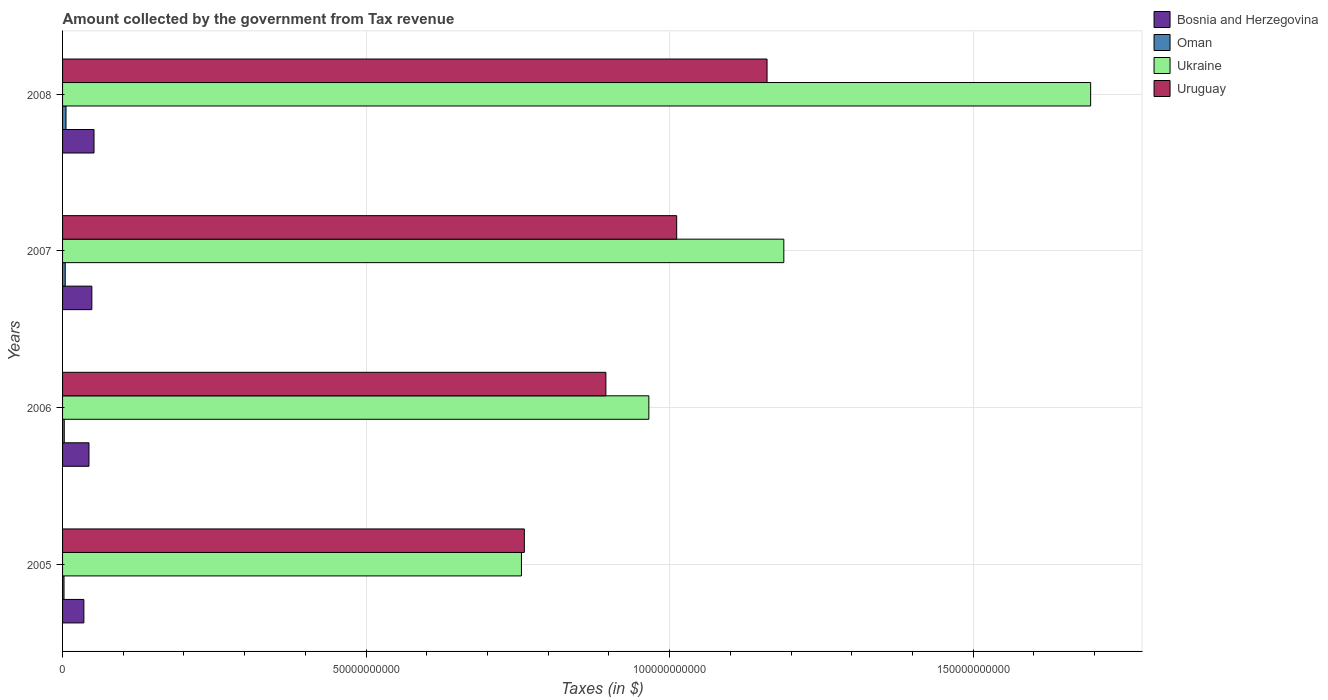Are the number of bars per tick equal to the number of legend labels?
Provide a short and direct response. Yes. How many bars are there on the 3rd tick from the bottom?
Your response must be concise. 4. What is the label of the 1st group of bars from the top?
Ensure brevity in your answer.  2008. In how many cases, is the number of bars for a given year not equal to the number of legend labels?
Ensure brevity in your answer.  0. What is the amount collected by the government from tax revenue in Oman in 2008?
Your answer should be compact. 5.66e+08. Across all years, what is the maximum amount collected by the government from tax revenue in Bosnia and Herzegovina?
Your answer should be very brief. 5.18e+09. Across all years, what is the minimum amount collected by the government from tax revenue in Uruguay?
Your answer should be compact. 7.61e+1. In which year was the amount collected by the government from tax revenue in Uruguay minimum?
Your answer should be very brief. 2005. What is the total amount collected by the government from tax revenue in Oman in the graph?
Offer a very short reply. 1.52e+09. What is the difference between the amount collected by the government from tax revenue in Oman in 2006 and that in 2008?
Provide a succinct answer. -2.88e+08. What is the difference between the amount collected by the government from tax revenue in Oman in 2005 and the amount collected by the government from tax revenue in Bosnia and Herzegovina in 2008?
Keep it short and to the point. -4.94e+09. What is the average amount collected by the government from tax revenue in Oman per year?
Make the answer very short. 3.80e+08. In the year 2006, what is the difference between the amount collected by the government from tax revenue in Uruguay and amount collected by the government from tax revenue in Bosnia and Herzegovina?
Your answer should be very brief. 8.51e+1. What is the ratio of the amount collected by the government from tax revenue in Oman in 2005 to that in 2006?
Make the answer very short. 0.86. What is the difference between the highest and the second highest amount collected by the government from tax revenue in Oman?
Your answer should be compact. 1.28e+08. What is the difference between the highest and the lowest amount collected by the government from tax revenue in Oman?
Provide a succinct answer. 3.27e+08. In how many years, is the amount collected by the government from tax revenue in Bosnia and Herzegovina greater than the average amount collected by the government from tax revenue in Bosnia and Herzegovina taken over all years?
Provide a succinct answer. 2. Is the sum of the amount collected by the government from tax revenue in Ukraine in 2005 and 2006 greater than the maximum amount collected by the government from tax revenue in Bosnia and Herzegovina across all years?
Your answer should be compact. Yes. Is it the case that in every year, the sum of the amount collected by the government from tax revenue in Oman and amount collected by the government from tax revenue in Ukraine is greater than the sum of amount collected by the government from tax revenue in Bosnia and Herzegovina and amount collected by the government from tax revenue in Uruguay?
Provide a short and direct response. Yes. What does the 2nd bar from the top in 2005 represents?
Give a very brief answer. Ukraine. What does the 2nd bar from the bottom in 2007 represents?
Ensure brevity in your answer.  Oman. Is it the case that in every year, the sum of the amount collected by the government from tax revenue in Oman and amount collected by the government from tax revenue in Bosnia and Herzegovina is greater than the amount collected by the government from tax revenue in Ukraine?
Your answer should be very brief. No. Are all the bars in the graph horizontal?
Your answer should be compact. Yes. How many years are there in the graph?
Your answer should be very brief. 4. Does the graph contain grids?
Provide a succinct answer. Yes. Where does the legend appear in the graph?
Your answer should be compact. Top right. How are the legend labels stacked?
Keep it short and to the point. Vertical. What is the title of the graph?
Provide a short and direct response. Amount collected by the government from Tax revenue. Does "Hungary" appear as one of the legend labels in the graph?
Keep it short and to the point. No. What is the label or title of the X-axis?
Provide a short and direct response. Taxes (in $). What is the label or title of the Y-axis?
Offer a terse response. Years. What is the Taxes (in $) of Bosnia and Herzegovina in 2005?
Your answer should be very brief. 3.51e+09. What is the Taxes (in $) in Oman in 2005?
Your response must be concise. 2.39e+08. What is the Taxes (in $) of Ukraine in 2005?
Provide a succinct answer. 7.56e+1. What is the Taxes (in $) of Uruguay in 2005?
Your response must be concise. 7.61e+1. What is the Taxes (in $) of Bosnia and Herzegovina in 2006?
Offer a very short reply. 4.35e+09. What is the Taxes (in $) in Oman in 2006?
Give a very brief answer. 2.78e+08. What is the Taxes (in $) in Ukraine in 2006?
Ensure brevity in your answer.  9.66e+1. What is the Taxes (in $) of Uruguay in 2006?
Your response must be concise. 8.95e+1. What is the Taxes (in $) in Bosnia and Herzegovina in 2007?
Ensure brevity in your answer.  4.82e+09. What is the Taxes (in $) of Oman in 2007?
Give a very brief answer. 4.38e+08. What is the Taxes (in $) of Ukraine in 2007?
Ensure brevity in your answer.  1.19e+11. What is the Taxes (in $) of Uruguay in 2007?
Offer a very short reply. 1.01e+11. What is the Taxes (in $) of Bosnia and Herzegovina in 2008?
Offer a terse response. 5.18e+09. What is the Taxes (in $) in Oman in 2008?
Provide a short and direct response. 5.66e+08. What is the Taxes (in $) of Ukraine in 2008?
Your answer should be very brief. 1.69e+11. What is the Taxes (in $) of Uruguay in 2008?
Provide a succinct answer. 1.16e+11. Across all years, what is the maximum Taxes (in $) of Bosnia and Herzegovina?
Ensure brevity in your answer.  5.18e+09. Across all years, what is the maximum Taxes (in $) in Oman?
Provide a short and direct response. 5.66e+08. Across all years, what is the maximum Taxes (in $) in Ukraine?
Ensure brevity in your answer.  1.69e+11. Across all years, what is the maximum Taxes (in $) in Uruguay?
Offer a terse response. 1.16e+11. Across all years, what is the minimum Taxes (in $) in Bosnia and Herzegovina?
Give a very brief answer. 3.51e+09. Across all years, what is the minimum Taxes (in $) of Oman?
Offer a terse response. 2.39e+08. Across all years, what is the minimum Taxes (in $) of Ukraine?
Ensure brevity in your answer.  7.56e+1. Across all years, what is the minimum Taxes (in $) of Uruguay?
Make the answer very short. 7.61e+1. What is the total Taxes (in $) of Bosnia and Herzegovina in the graph?
Your answer should be compact. 1.79e+1. What is the total Taxes (in $) in Oman in the graph?
Provide a succinct answer. 1.52e+09. What is the total Taxes (in $) in Ukraine in the graph?
Ensure brevity in your answer.  4.60e+11. What is the total Taxes (in $) in Uruguay in the graph?
Ensure brevity in your answer.  3.83e+11. What is the difference between the Taxes (in $) of Bosnia and Herzegovina in 2005 and that in 2006?
Make the answer very short. -8.40e+08. What is the difference between the Taxes (in $) in Oman in 2005 and that in 2006?
Provide a succinct answer. -3.95e+07. What is the difference between the Taxes (in $) in Ukraine in 2005 and that in 2006?
Provide a succinct answer. -2.10e+1. What is the difference between the Taxes (in $) of Uruguay in 2005 and that in 2006?
Give a very brief answer. -1.34e+1. What is the difference between the Taxes (in $) of Bosnia and Herzegovina in 2005 and that in 2007?
Offer a terse response. -1.31e+09. What is the difference between the Taxes (in $) in Oman in 2005 and that in 2007?
Your answer should be compact. -1.99e+08. What is the difference between the Taxes (in $) in Ukraine in 2005 and that in 2007?
Offer a very short reply. -4.32e+1. What is the difference between the Taxes (in $) of Uruguay in 2005 and that in 2007?
Offer a very short reply. -2.51e+1. What is the difference between the Taxes (in $) of Bosnia and Herzegovina in 2005 and that in 2008?
Offer a terse response. -1.67e+09. What is the difference between the Taxes (in $) of Oman in 2005 and that in 2008?
Your answer should be very brief. -3.27e+08. What is the difference between the Taxes (in $) in Ukraine in 2005 and that in 2008?
Provide a short and direct response. -9.38e+1. What is the difference between the Taxes (in $) of Uruguay in 2005 and that in 2008?
Provide a succinct answer. -4.00e+1. What is the difference between the Taxes (in $) of Bosnia and Herzegovina in 2006 and that in 2007?
Your answer should be compact. -4.74e+08. What is the difference between the Taxes (in $) in Oman in 2006 and that in 2007?
Give a very brief answer. -1.59e+08. What is the difference between the Taxes (in $) in Ukraine in 2006 and that in 2007?
Your answer should be very brief. -2.22e+1. What is the difference between the Taxes (in $) of Uruguay in 2006 and that in 2007?
Keep it short and to the point. -1.17e+1. What is the difference between the Taxes (in $) of Bosnia and Herzegovina in 2006 and that in 2008?
Your response must be concise. -8.31e+08. What is the difference between the Taxes (in $) in Oman in 2006 and that in 2008?
Offer a very short reply. -2.88e+08. What is the difference between the Taxes (in $) in Ukraine in 2006 and that in 2008?
Provide a short and direct response. -7.28e+1. What is the difference between the Taxes (in $) of Uruguay in 2006 and that in 2008?
Keep it short and to the point. -2.65e+1. What is the difference between the Taxes (in $) of Bosnia and Herzegovina in 2007 and that in 2008?
Ensure brevity in your answer.  -3.57e+08. What is the difference between the Taxes (in $) in Oman in 2007 and that in 2008?
Provide a short and direct response. -1.28e+08. What is the difference between the Taxes (in $) of Ukraine in 2007 and that in 2008?
Provide a succinct answer. -5.05e+1. What is the difference between the Taxes (in $) of Uruguay in 2007 and that in 2008?
Ensure brevity in your answer.  -1.49e+1. What is the difference between the Taxes (in $) of Bosnia and Herzegovina in 2005 and the Taxes (in $) of Oman in 2006?
Provide a short and direct response. 3.23e+09. What is the difference between the Taxes (in $) in Bosnia and Herzegovina in 2005 and the Taxes (in $) in Ukraine in 2006?
Your answer should be very brief. -9.31e+1. What is the difference between the Taxes (in $) in Bosnia and Herzegovina in 2005 and the Taxes (in $) in Uruguay in 2006?
Provide a short and direct response. -8.60e+1. What is the difference between the Taxes (in $) of Oman in 2005 and the Taxes (in $) of Ukraine in 2006?
Your answer should be compact. -9.63e+1. What is the difference between the Taxes (in $) of Oman in 2005 and the Taxes (in $) of Uruguay in 2006?
Provide a succinct answer. -8.93e+1. What is the difference between the Taxes (in $) in Ukraine in 2005 and the Taxes (in $) in Uruguay in 2006?
Ensure brevity in your answer.  -1.39e+1. What is the difference between the Taxes (in $) of Bosnia and Herzegovina in 2005 and the Taxes (in $) of Oman in 2007?
Give a very brief answer. 3.07e+09. What is the difference between the Taxes (in $) of Bosnia and Herzegovina in 2005 and the Taxes (in $) of Ukraine in 2007?
Keep it short and to the point. -1.15e+11. What is the difference between the Taxes (in $) of Bosnia and Herzegovina in 2005 and the Taxes (in $) of Uruguay in 2007?
Provide a short and direct response. -9.77e+1. What is the difference between the Taxes (in $) of Oman in 2005 and the Taxes (in $) of Ukraine in 2007?
Ensure brevity in your answer.  -1.19e+11. What is the difference between the Taxes (in $) in Oman in 2005 and the Taxes (in $) in Uruguay in 2007?
Provide a short and direct response. -1.01e+11. What is the difference between the Taxes (in $) of Ukraine in 2005 and the Taxes (in $) of Uruguay in 2007?
Provide a short and direct response. -2.56e+1. What is the difference between the Taxes (in $) in Bosnia and Herzegovina in 2005 and the Taxes (in $) in Oman in 2008?
Your answer should be compact. 2.94e+09. What is the difference between the Taxes (in $) of Bosnia and Herzegovina in 2005 and the Taxes (in $) of Ukraine in 2008?
Keep it short and to the point. -1.66e+11. What is the difference between the Taxes (in $) in Bosnia and Herzegovina in 2005 and the Taxes (in $) in Uruguay in 2008?
Provide a succinct answer. -1.13e+11. What is the difference between the Taxes (in $) in Oman in 2005 and the Taxes (in $) in Ukraine in 2008?
Provide a short and direct response. -1.69e+11. What is the difference between the Taxes (in $) in Oman in 2005 and the Taxes (in $) in Uruguay in 2008?
Offer a terse response. -1.16e+11. What is the difference between the Taxes (in $) in Ukraine in 2005 and the Taxes (in $) in Uruguay in 2008?
Give a very brief answer. -4.05e+1. What is the difference between the Taxes (in $) of Bosnia and Herzegovina in 2006 and the Taxes (in $) of Oman in 2007?
Provide a succinct answer. 3.91e+09. What is the difference between the Taxes (in $) in Bosnia and Herzegovina in 2006 and the Taxes (in $) in Ukraine in 2007?
Keep it short and to the point. -1.14e+11. What is the difference between the Taxes (in $) of Bosnia and Herzegovina in 2006 and the Taxes (in $) of Uruguay in 2007?
Keep it short and to the point. -9.68e+1. What is the difference between the Taxes (in $) of Oman in 2006 and the Taxes (in $) of Ukraine in 2007?
Provide a short and direct response. -1.19e+11. What is the difference between the Taxes (in $) in Oman in 2006 and the Taxes (in $) in Uruguay in 2007?
Provide a succinct answer. -1.01e+11. What is the difference between the Taxes (in $) of Ukraine in 2006 and the Taxes (in $) of Uruguay in 2007?
Provide a succinct answer. -4.59e+09. What is the difference between the Taxes (in $) of Bosnia and Herzegovina in 2006 and the Taxes (in $) of Oman in 2008?
Offer a very short reply. 3.78e+09. What is the difference between the Taxes (in $) in Bosnia and Herzegovina in 2006 and the Taxes (in $) in Ukraine in 2008?
Your answer should be compact. -1.65e+11. What is the difference between the Taxes (in $) of Bosnia and Herzegovina in 2006 and the Taxes (in $) of Uruguay in 2008?
Give a very brief answer. -1.12e+11. What is the difference between the Taxes (in $) of Oman in 2006 and the Taxes (in $) of Ukraine in 2008?
Your response must be concise. -1.69e+11. What is the difference between the Taxes (in $) in Oman in 2006 and the Taxes (in $) in Uruguay in 2008?
Your response must be concise. -1.16e+11. What is the difference between the Taxes (in $) of Ukraine in 2006 and the Taxes (in $) of Uruguay in 2008?
Your answer should be compact. -1.95e+1. What is the difference between the Taxes (in $) in Bosnia and Herzegovina in 2007 and the Taxes (in $) in Oman in 2008?
Ensure brevity in your answer.  4.26e+09. What is the difference between the Taxes (in $) of Bosnia and Herzegovina in 2007 and the Taxes (in $) of Ukraine in 2008?
Ensure brevity in your answer.  -1.65e+11. What is the difference between the Taxes (in $) in Bosnia and Herzegovina in 2007 and the Taxes (in $) in Uruguay in 2008?
Your answer should be compact. -1.11e+11. What is the difference between the Taxes (in $) of Oman in 2007 and the Taxes (in $) of Ukraine in 2008?
Offer a terse response. -1.69e+11. What is the difference between the Taxes (in $) of Oman in 2007 and the Taxes (in $) of Uruguay in 2008?
Your response must be concise. -1.16e+11. What is the difference between the Taxes (in $) in Ukraine in 2007 and the Taxes (in $) in Uruguay in 2008?
Your response must be concise. 2.76e+09. What is the average Taxes (in $) in Bosnia and Herzegovina per year?
Your response must be concise. 4.47e+09. What is the average Taxes (in $) in Oman per year?
Keep it short and to the point. 3.80e+08. What is the average Taxes (in $) in Ukraine per year?
Offer a terse response. 1.15e+11. What is the average Taxes (in $) in Uruguay per year?
Provide a short and direct response. 9.57e+1. In the year 2005, what is the difference between the Taxes (in $) of Bosnia and Herzegovina and Taxes (in $) of Oman?
Offer a terse response. 3.27e+09. In the year 2005, what is the difference between the Taxes (in $) of Bosnia and Herzegovina and Taxes (in $) of Ukraine?
Offer a terse response. -7.21e+1. In the year 2005, what is the difference between the Taxes (in $) in Bosnia and Herzegovina and Taxes (in $) in Uruguay?
Make the answer very short. -7.26e+1. In the year 2005, what is the difference between the Taxes (in $) of Oman and Taxes (in $) of Ukraine?
Offer a terse response. -7.54e+1. In the year 2005, what is the difference between the Taxes (in $) in Oman and Taxes (in $) in Uruguay?
Your response must be concise. -7.58e+1. In the year 2005, what is the difference between the Taxes (in $) in Ukraine and Taxes (in $) in Uruguay?
Keep it short and to the point. -4.75e+08. In the year 2006, what is the difference between the Taxes (in $) in Bosnia and Herzegovina and Taxes (in $) in Oman?
Ensure brevity in your answer.  4.07e+09. In the year 2006, what is the difference between the Taxes (in $) of Bosnia and Herzegovina and Taxes (in $) of Ukraine?
Provide a short and direct response. -9.22e+1. In the year 2006, what is the difference between the Taxes (in $) of Bosnia and Herzegovina and Taxes (in $) of Uruguay?
Your answer should be compact. -8.51e+1. In the year 2006, what is the difference between the Taxes (in $) of Oman and Taxes (in $) of Ukraine?
Your answer should be compact. -9.63e+1. In the year 2006, what is the difference between the Taxes (in $) in Oman and Taxes (in $) in Uruguay?
Your response must be concise. -8.92e+1. In the year 2006, what is the difference between the Taxes (in $) of Ukraine and Taxes (in $) of Uruguay?
Offer a very short reply. 7.07e+09. In the year 2007, what is the difference between the Taxes (in $) of Bosnia and Herzegovina and Taxes (in $) of Oman?
Make the answer very short. 4.39e+09. In the year 2007, what is the difference between the Taxes (in $) of Bosnia and Herzegovina and Taxes (in $) of Ukraine?
Make the answer very short. -1.14e+11. In the year 2007, what is the difference between the Taxes (in $) of Bosnia and Herzegovina and Taxes (in $) of Uruguay?
Provide a succinct answer. -9.63e+1. In the year 2007, what is the difference between the Taxes (in $) in Oman and Taxes (in $) in Ukraine?
Provide a succinct answer. -1.18e+11. In the year 2007, what is the difference between the Taxes (in $) of Oman and Taxes (in $) of Uruguay?
Your response must be concise. -1.01e+11. In the year 2007, what is the difference between the Taxes (in $) in Ukraine and Taxes (in $) in Uruguay?
Your response must be concise. 1.76e+1. In the year 2008, what is the difference between the Taxes (in $) in Bosnia and Herzegovina and Taxes (in $) in Oman?
Give a very brief answer. 4.62e+09. In the year 2008, what is the difference between the Taxes (in $) of Bosnia and Herzegovina and Taxes (in $) of Ukraine?
Keep it short and to the point. -1.64e+11. In the year 2008, what is the difference between the Taxes (in $) of Bosnia and Herzegovina and Taxes (in $) of Uruguay?
Offer a very short reply. -1.11e+11. In the year 2008, what is the difference between the Taxes (in $) in Oman and Taxes (in $) in Ukraine?
Offer a very short reply. -1.69e+11. In the year 2008, what is the difference between the Taxes (in $) of Oman and Taxes (in $) of Uruguay?
Make the answer very short. -1.15e+11. In the year 2008, what is the difference between the Taxes (in $) in Ukraine and Taxes (in $) in Uruguay?
Offer a terse response. 5.33e+1. What is the ratio of the Taxes (in $) in Bosnia and Herzegovina in 2005 to that in 2006?
Provide a succinct answer. 0.81. What is the ratio of the Taxes (in $) of Oman in 2005 to that in 2006?
Provide a short and direct response. 0.86. What is the ratio of the Taxes (in $) of Ukraine in 2005 to that in 2006?
Offer a terse response. 0.78. What is the ratio of the Taxes (in $) of Uruguay in 2005 to that in 2006?
Keep it short and to the point. 0.85. What is the ratio of the Taxes (in $) of Bosnia and Herzegovina in 2005 to that in 2007?
Offer a very short reply. 0.73. What is the ratio of the Taxes (in $) in Oman in 2005 to that in 2007?
Offer a terse response. 0.55. What is the ratio of the Taxes (in $) in Ukraine in 2005 to that in 2007?
Offer a very short reply. 0.64. What is the ratio of the Taxes (in $) in Uruguay in 2005 to that in 2007?
Provide a succinct answer. 0.75. What is the ratio of the Taxes (in $) of Bosnia and Herzegovina in 2005 to that in 2008?
Your answer should be compact. 0.68. What is the ratio of the Taxes (in $) in Oman in 2005 to that in 2008?
Your answer should be compact. 0.42. What is the ratio of the Taxes (in $) in Ukraine in 2005 to that in 2008?
Offer a very short reply. 0.45. What is the ratio of the Taxes (in $) of Uruguay in 2005 to that in 2008?
Offer a very short reply. 0.66. What is the ratio of the Taxes (in $) in Bosnia and Herzegovina in 2006 to that in 2007?
Provide a short and direct response. 0.9. What is the ratio of the Taxes (in $) in Oman in 2006 to that in 2007?
Give a very brief answer. 0.64. What is the ratio of the Taxes (in $) in Ukraine in 2006 to that in 2007?
Make the answer very short. 0.81. What is the ratio of the Taxes (in $) in Uruguay in 2006 to that in 2007?
Offer a very short reply. 0.88. What is the ratio of the Taxes (in $) of Bosnia and Herzegovina in 2006 to that in 2008?
Your response must be concise. 0.84. What is the ratio of the Taxes (in $) of Oman in 2006 to that in 2008?
Ensure brevity in your answer.  0.49. What is the ratio of the Taxes (in $) of Ukraine in 2006 to that in 2008?
Provide a short and direct response. 0.57. What is the ratio of the Taxes (in $) in Uruguay in 2006 to that in 2008?
Make the answer very short. 0.77. What is the ratio of the Taxes (in $) of Bosnia and Herzegovina in 2007 to that in 2008?
Offer a terse response. 0.93. What is the ratio of the Taxes (in $) of Oman in 2007 to that in 2008?
Provide a succinct answer. 0.77. What is the ratio of the Taxes (in $) of Ukraine in 2007 to that in 2008?
Keep it short and to the point. 0.7. What is the ratio of the Taxes (in $) in Uruguay in 2007 to that in 2008?
Make the answer very short. 0.87. What is the difference between the highest and the second highest Taxes (in $) of Bosnia and Herzegovina?
Keep it short and to the point. 3.57e+08. What is the difference between the highest and the second highest Taxes (in $) in Oman?
Give a very brief answer. 1.28e+08. What is the difference between the highest and the second highest Taxes (in $) in Ukraine?
Your answer should be compact. 5.05e+1. What is the difference between the highest and the second highest Taxes (in $) of Uruguay?
Provide a succinct answer. 1.49e+1. What is the difference between the highest and the lowest Taxes (in $) in Bosnia and Herzegovina?
Provide a succinct answer. 1.67e+09. What is the difference between the highest and the lowest Taxes (in $) in Oman?
Your answer should be compact. 3.27e+08. What is the difference between the highest and the lowest Taxes (in $) in Ukraine?
Make the answer very short. 9.38e+1. What is the difference between the highest and the lowest Taxes (in $) of Uruguay?
Offer a very short reply. 4.00e+1. 